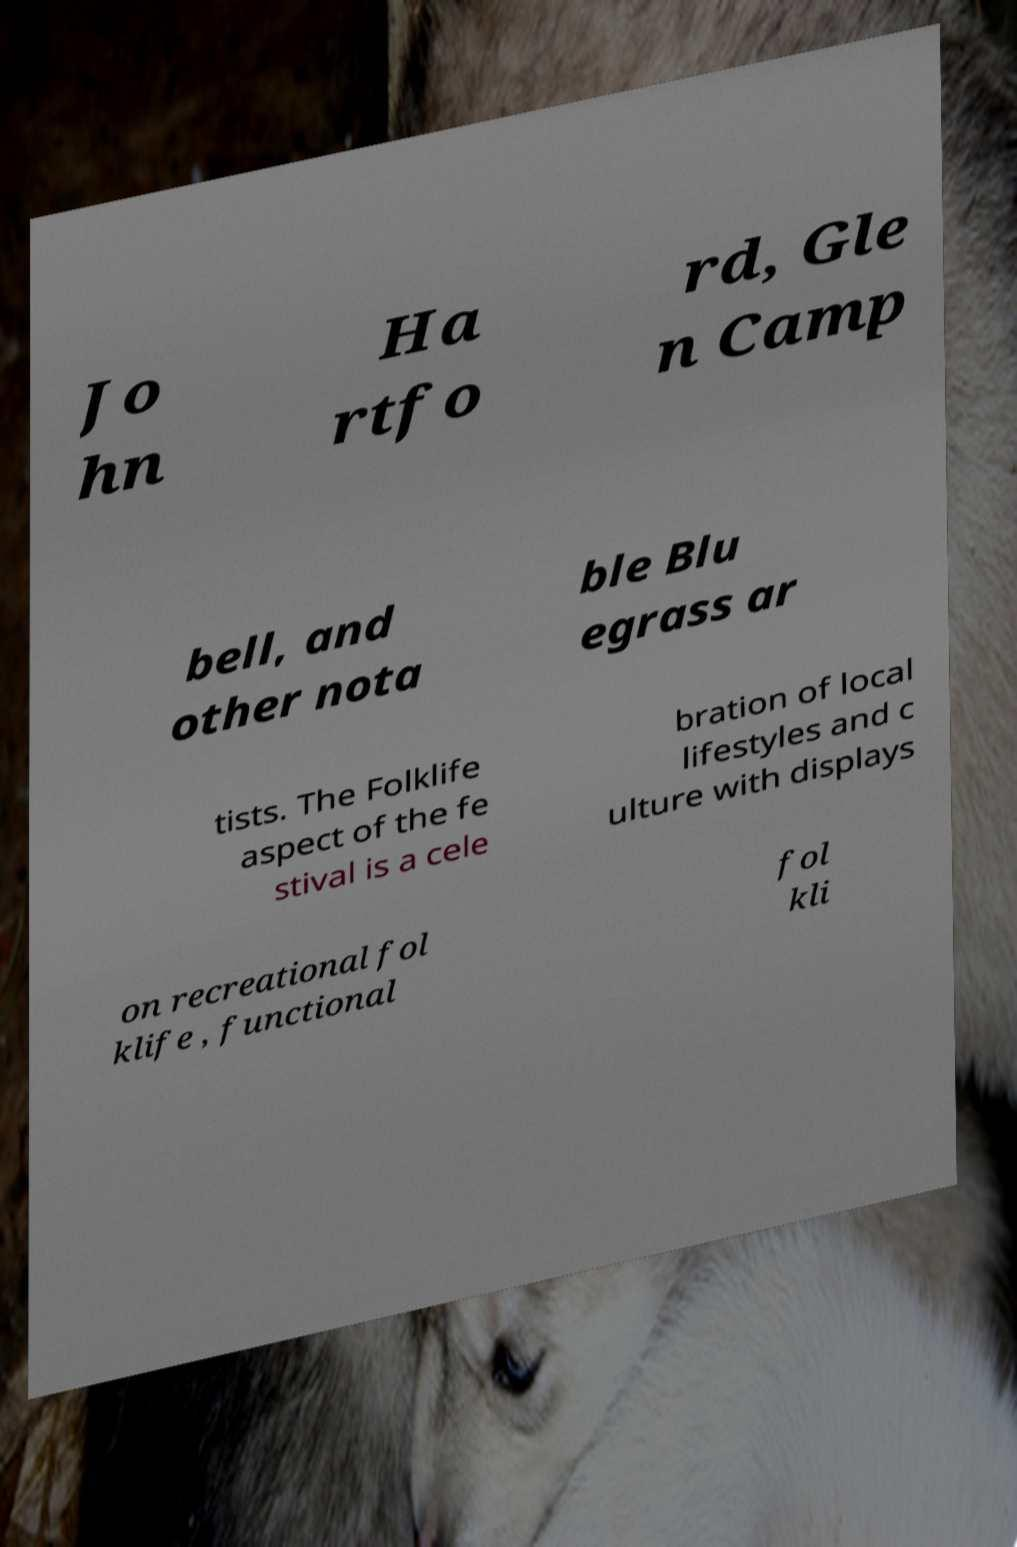Can you read and provide the text displayed in the image?This photo seems to have some interesting text. Can you extract and type it out for me? Jo hn Ha rtfo rd, Gle n Camp bell, and other nota ble Blu egrass ar tists. The Folklife aspect of the fe stival is a cele bration of local lifestyles and c ulture with displays on recreational fol klife , functional fol kli 